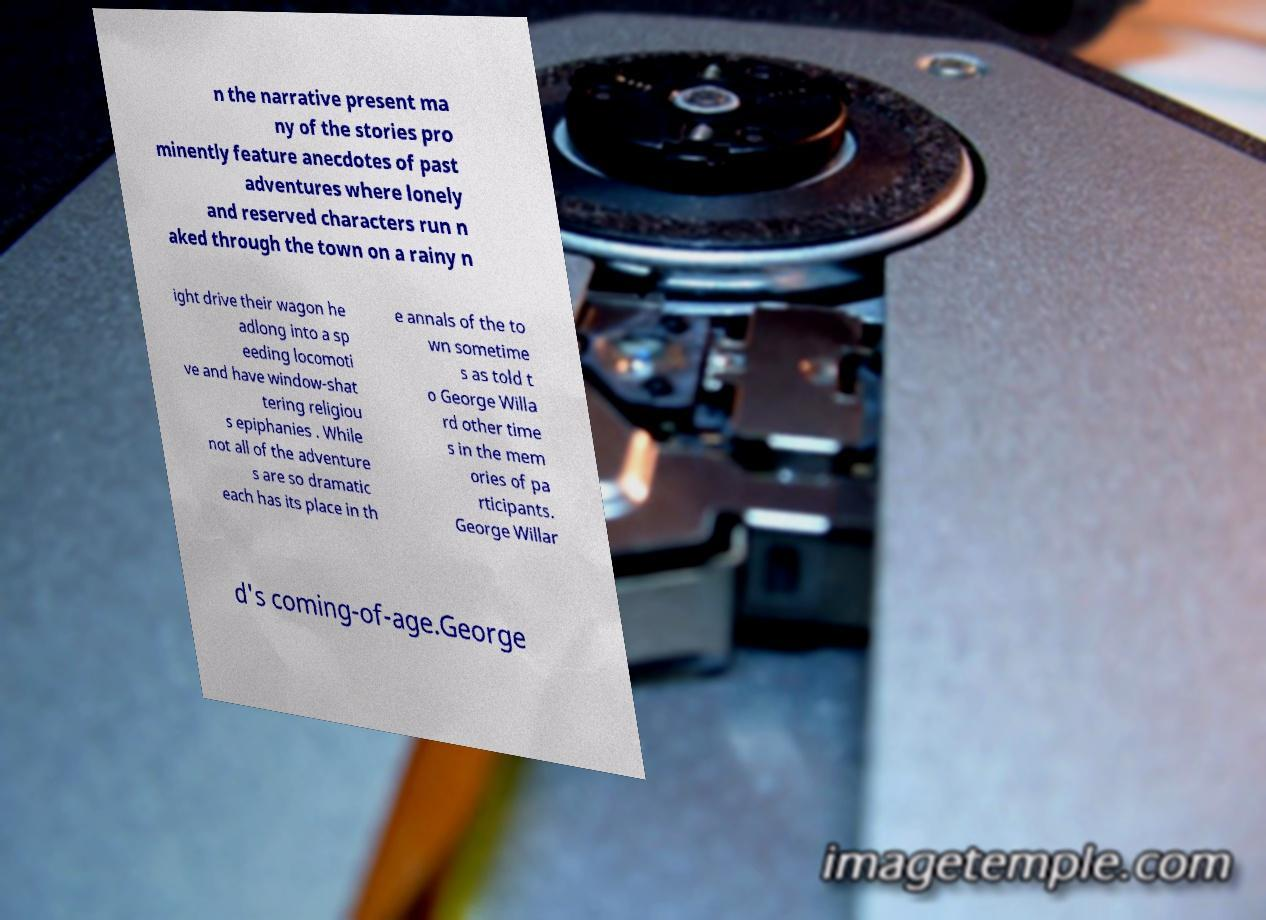Please read and relay the text visible in this image. What does it say? n the narrative present ma ny of the stories pro minently feature anecdotes of past adventures where lonely and reserved characters run n aked through the town on a rainy n ight drive their wagon he adlong into a sp eeding locomoti ve and have window-shat tering religiou s epiphanies . While not all of the adventure s are so dramatic each has its place in th e annals of the to wn sometime s as told t o George Willa rd other time s in the mem ories of pa rticipants. George Willar d's coming-of-age.George 